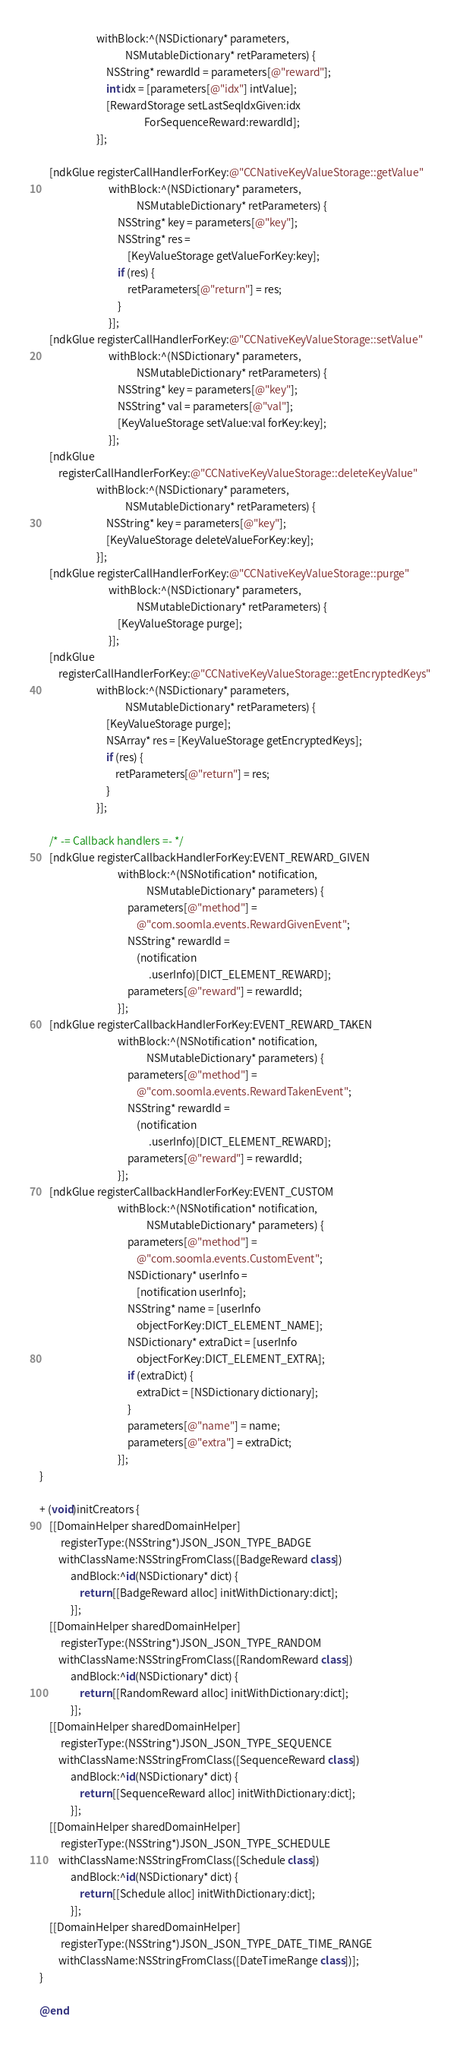Convert code to text. <code><loc_0><loc_0><loc_500><loc_500><_ObjectiveC_>                        withBlock:^(NSDictionary* parameters,
                                    NSMutableDictionary* retParameters) {
                            NSString* rewardId = parameters[@"reward"];
                            int idx = [parameters[@"idx"] intValue];
                            [RewardStorage setLastSeqIdxGiven:idx
                                            ForSequenceReward:rewardId];
                        }];

    [ndkGlue registerCallHandlerForKey:@"CCNativeKeyValueStorage::getValue"
                             withBlock:^(NSDictionary* parameters,
                                         NSMutableDictionary* retParameters) {
                                 NSString* key = parameters[@"key"];
                                 NSString* res =
                                     [KeyValueStorage getValueForKey:key];
                                 if (res) {
                                     retParameters[@"return"] = res;
                                 }
                             }];
    [ndkGlue registerCallHandlerForKey:@"CCNativeKeyValueStorage::setValue"
                             withBlock:^(NSDictionary* parameters,
                                         NSMutableDictionary* retParameters) {
                                 NSString* key = parameters[@"key"];
                                 NSString* val = parameters[@"val"];
                                 [KeyValueStorage setValue:val forKey:key];
                             }];
    [ndkGlue
        registerCallHandlerForKey:@"CCNativeKeyValueStorage::deleteKeyValue"
                        withBlock:^(NSDictionary* parameters,
                                    NSMutableDictionary* retParameters) {
                            NSString* key = parameters[@"key"];
                            [KeyValueStorage deleteValueForKey:key];
                        }];
    [ndkGlue registerCallHandlerForKey:@"CCNativeKeyValueStorage::purge"
                             withBlock:^(NSDictionary* parameters,
                                         NSMutableDictionary* retParameters) {
                                 [KeyValueStorage purge];
                             }];
    [ndkGlue
        registerCallHandlerForKey:@"CCNativeKeyValueStorage::getEncryptedKeys"
                        withBlock:^(NSDictionary* parameters,
                                    NSMutableDictionary* retParameters) {
                            [KeyValueStorage purge];
                            NSArray* res = [KeyValueStorage getEncryptedKeys];
                            if (res) {
                                retParameters[@"return"] = res;
                            }
                        }];

    /* -= Callback handlers =- */
    [ndkGlue registerCallbackHandlerForKey:EVENT_REWARD_GIVEN
                                 withBlock:^(NSNotification* notification,
                                             NSMutableDictionary* parameters) {
                                     parameters[@"method"] =
                                         @"com.soomla.events.RewardGivenEvent";
                                     NSString* rewardId =
                                         (notification
                                              .userInfo)[DICT_ELEMENT_REWARD];
                                     parameters[@"reward"] = rewardId;
                                 }];
    [ndkGlue registerCallbackHandlerForKey:EVENT_REWARD_TAKEN
                                 withBlock:^(NSNotification* notification,
                                             NSMutableDictionary* parameters) {
                                     parameters[@"method"] =
                                         @"com.soomla.events.RewardTakenEvent";
                                     NSString* rewardId =
                                         (notification
                                              .userInfo)[DICT_ELEMENT_REWARD];
                                     parameters[@"reward"] = rewardId;
                                 }];
    [ndkGlue registerCallbackHandlerForKey:EVENT_CUSTOM
                                 withBlock:^(NSNotification* notification,
                                             NSMutableDictionary* parameters) {
                                     parameters[@"method"] =
                                         @"com.soomla.events.CustomEvent";
                                     NSDictionary* userInfo =
                                         [notification userInfo];
                                     NSString* name = [userInfo
                                         objectForKey:DICT_ELEMENT_NAME];
                                     NSDictionary* extraDict = [userInfo
                                         objectForKey:DICT_ELEMENT_EXTRA];
                                     if (extraDict) {
                                         extraDict = [NSDictionary dictionary];
                                     }
                                     parameters[@"name"] = name;
                                     parameters[@"extra"] = extraDict;
                                 }];
}

+ (void)initCreators {
    [[DomainHelper sharedDomainHelper]
         registerType:(NSString*)JSON_JSON_TYPE_BADGE
        withClassName:NSStringFromClass([BadgeReward class])
             andBlock:^id(NSDictionary* dict) {
                 return [[BadgeReward alloc] initWithDictionary:dict];
             }];
    [[DomainHelper sharedDomainHelper]
         registerType:(NSString*)JSON_JSON_TYPE_RANDOM
        withClassName:NSStringFromClass([RandomReward class])
             andBlock:^id(NSDictionary* dict) {
                 return [[RandomReward alloc] initWithDictionary:dict];
             }];
    [[DomainHelper sharedDomainHelper]
         registerType:(NSString*)JSON_JSON_TYPE_SEQUENCE
        withClassName:NSStringFromClass([SequenceReward class])
             andBlock:^id(NSDictionary* dict) {
                 return [[SequenceReward alloc] initWithDictionary:dict];
             }];
    [[DomainHelper sharedDomainHelper]
         registerType:(NSString*)JSON_JSON_TYPE_SCHEDULE
        withClassName:NSStringFromClass([Schedule class])
             andBlock:^id(NSDictionary* dict) {
                 return [[Schedule alloc] initWithDictionary:dict];
             }];
    [[DomainHelper sharedDomainHelper]
         registerType:(NSString*)JSON_JSON_TYPE_DATE_TIME_RANGE
        withClassName:NSStringFromClass([DateTimeRange class])];
}

@end
</code> 